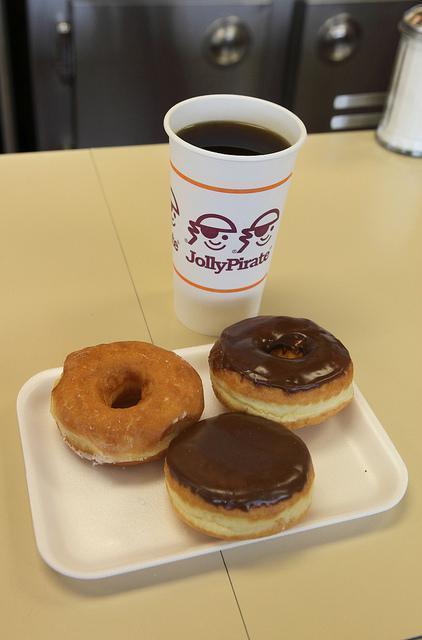How many doughnut do you see?
Give a very brief answer. 3. How many desserts are on each plate?
Give a very brief answer. 3. How many donuts are there?
Give a very brief answer. 3. How many women on bikes are in the picture?
Give a very brief answer. 0. 